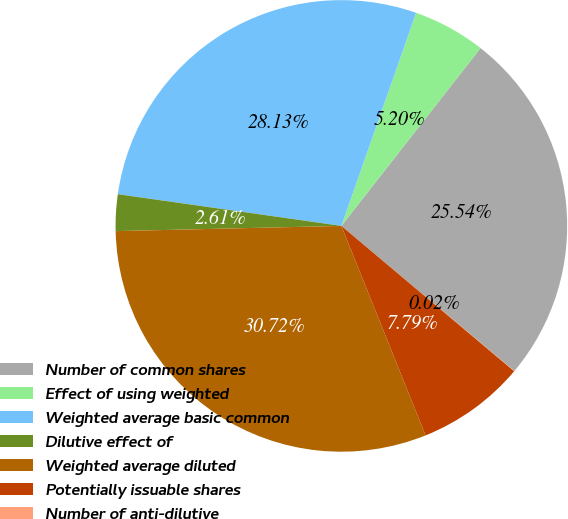Convert chart to OTSL. <chart><loc_0><loc_0><loc_500><loc_500><pie_chart><fcel>Number of common shares<fcel>Effect of using weighted<fcel>Weighted average basic common<fcel>Dilutive effect of<fcel>Weighted average diluted<fcel>Potentially issuable shares<fcel>Number of anti-dilutive<nl><fcel>25.54%<fcel>5.2%<fcel>28.13%<fcel>2.61%<fcel>30.72%<fcel>7.79%<fcel>0.02%<nl></chart> 